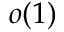<formula> <loc_0><loc_0><loc_500><loc_500>o ( 1 )</formula> 